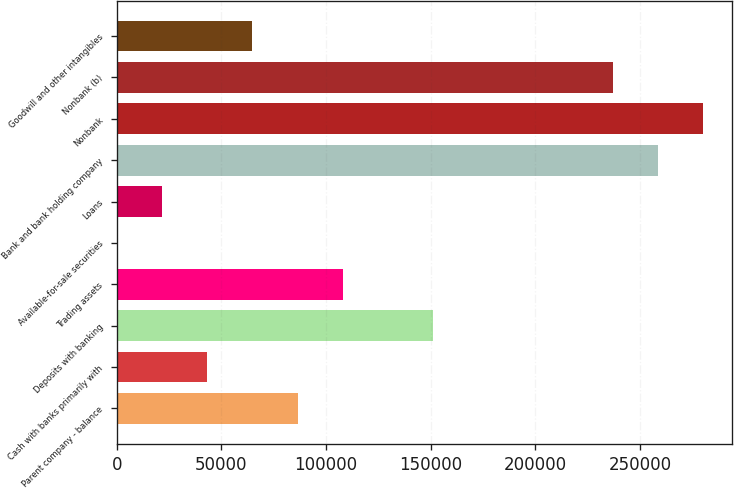Convert chart to OTSL. <chart><loc_0><loc_0><loc_500><loc_500><bar_chart><fcel>Parent company - balance<fcel>Cash with banks primarily with<fcel>Deposits with banking<fcel>Trading assets<fcel>Available-for-sale securities<fcel>Loans<fcel>Bank and bank holding company<fcel>Nonbank<fcel>Nonbank (b)<fcel>Goodwill and other intangibles<nl><fcel>86407.8<fcel>43346.4<fcel>151000<fcel>107938<fcel>285<fcel>21815.7<fcel>258653<fcel>280184<fcel>237123<fcel>64877.1<nl></chart> 